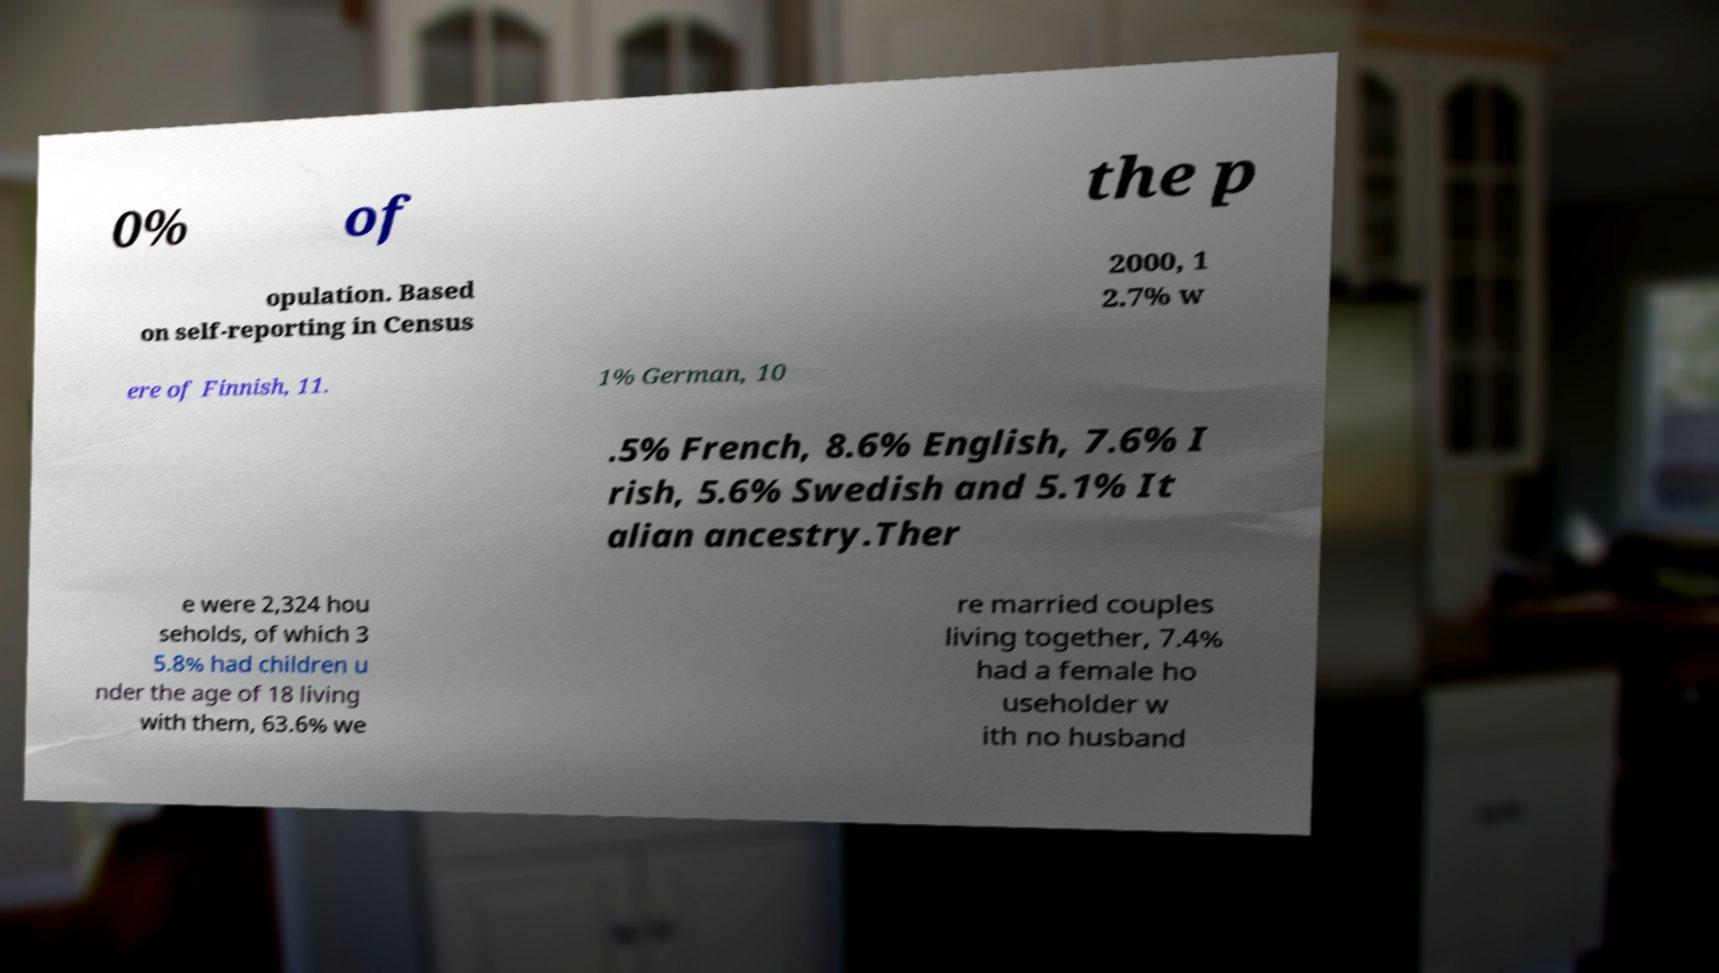Could you extract and type out the text from this image? 0% of the p opulation. Based on self-reporting in Census 2000, 1 2.7% w ere of Finnish, 11. 1% German, 10 .5% French, 8.6% English, 7.6% I rish, 5.6% Swedish and 5.1% It alian ancestry.Ther e were 2,324 hou seholds, of which 3 5.8% had children u nder the age of 18 living with them, 63.6% we re married couples living together, 7.4% had a female ho useholder w ith no husband 